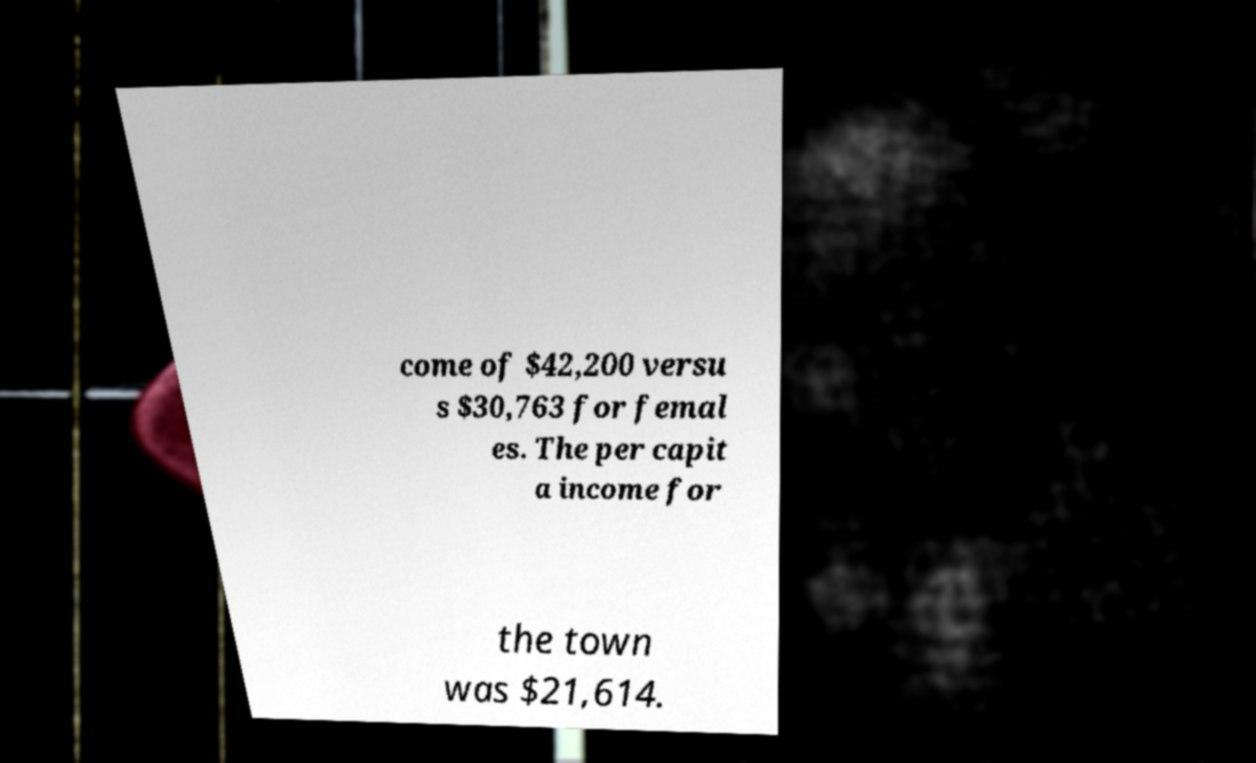I need the written content from this picture converted into text. Can you do that? come of $42,200 versu s $30,763 for femal es. The per capit a income for the town was $21,614. 